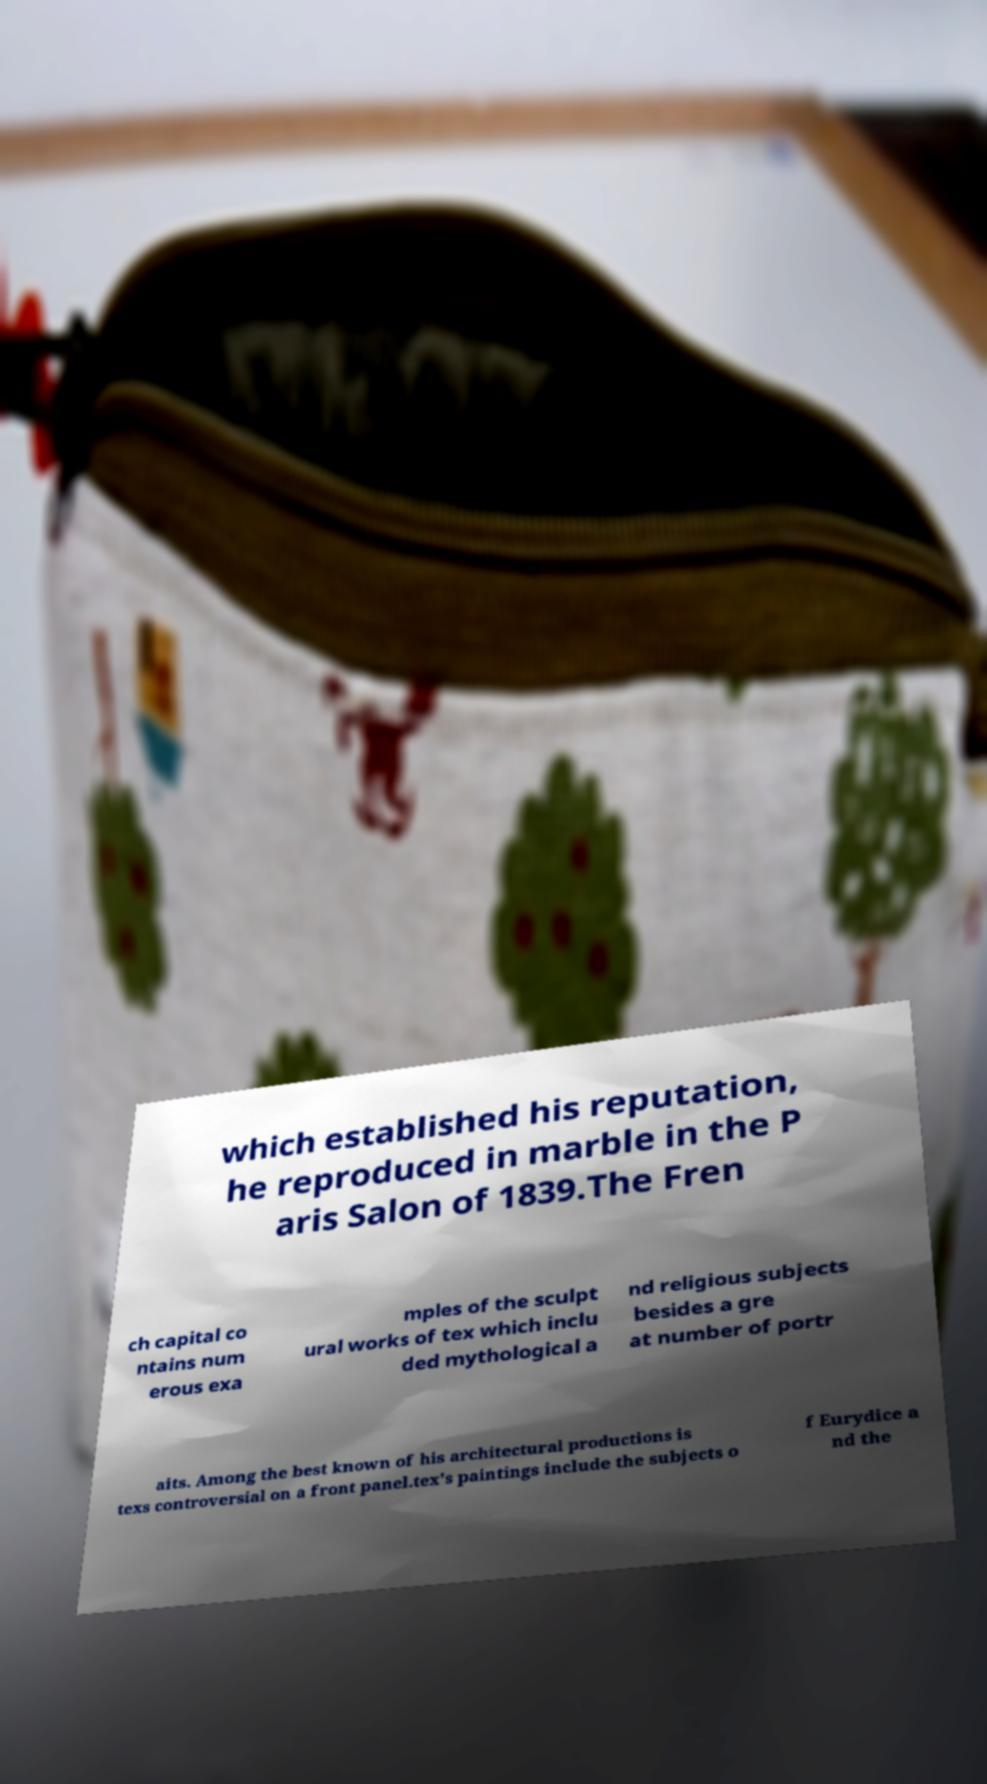What messages or text are displayed in this image? I need them in a readable, typed format. which established his reputation, he reproduced in marble in the P aris Salon of 1839.The Fren ch capital co ntains num erous exa mples of the sculpt ural works of tex which inclu ded mythological a nd religious subjects besides a gre at number of portr aits. Among the best known of his architectural productions is texs controversial on a front panel.tex's paintings include the subjects o f Eurydice a nd the 